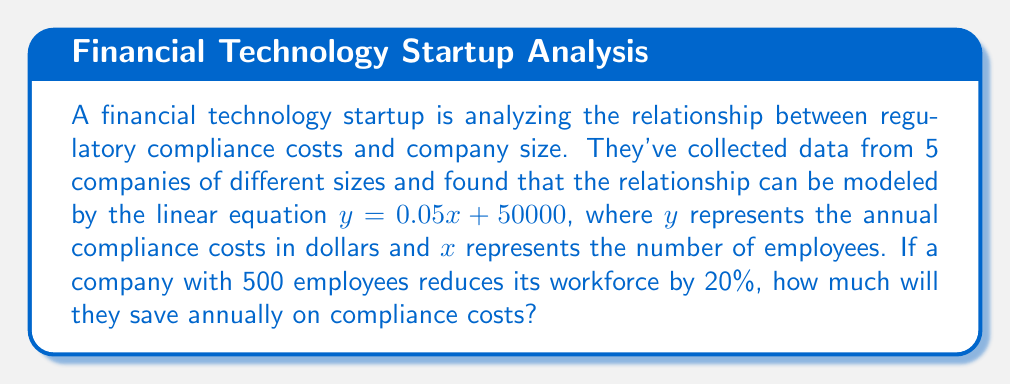Help me with this question. 1. Understand the given equation:
   $y = 0.05x + 50000$, where:
   $y$ = annual compliance costs in dollars
   $x$ = number of employees

2. Calculate the initial compliance costs for 500 employees:
   $y_1 = 0.05(500) + 50000 = 25000 + 50000 = 75000$

3. Calculate the new number of employees after 20% reduction:
   New employees = $500 - (20\% \times 500) = 500 - 100 = 400$

4. Calculate the new compliance costs for 400 employees:
   $y_2 = 0.05(400) + 50000 = 20000 + 50000 = 70000$

5. Calculate the difference in compliance costs:
   Savings = $y_1 - y_2 = 75000 - 70000 = 5000$
Answer: $5000 